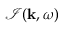Convert formula to latex. <formula><loc_0><loc_0><loc_500><loc_500>\mathcal { I } ( { k } , \omega )</formula> 